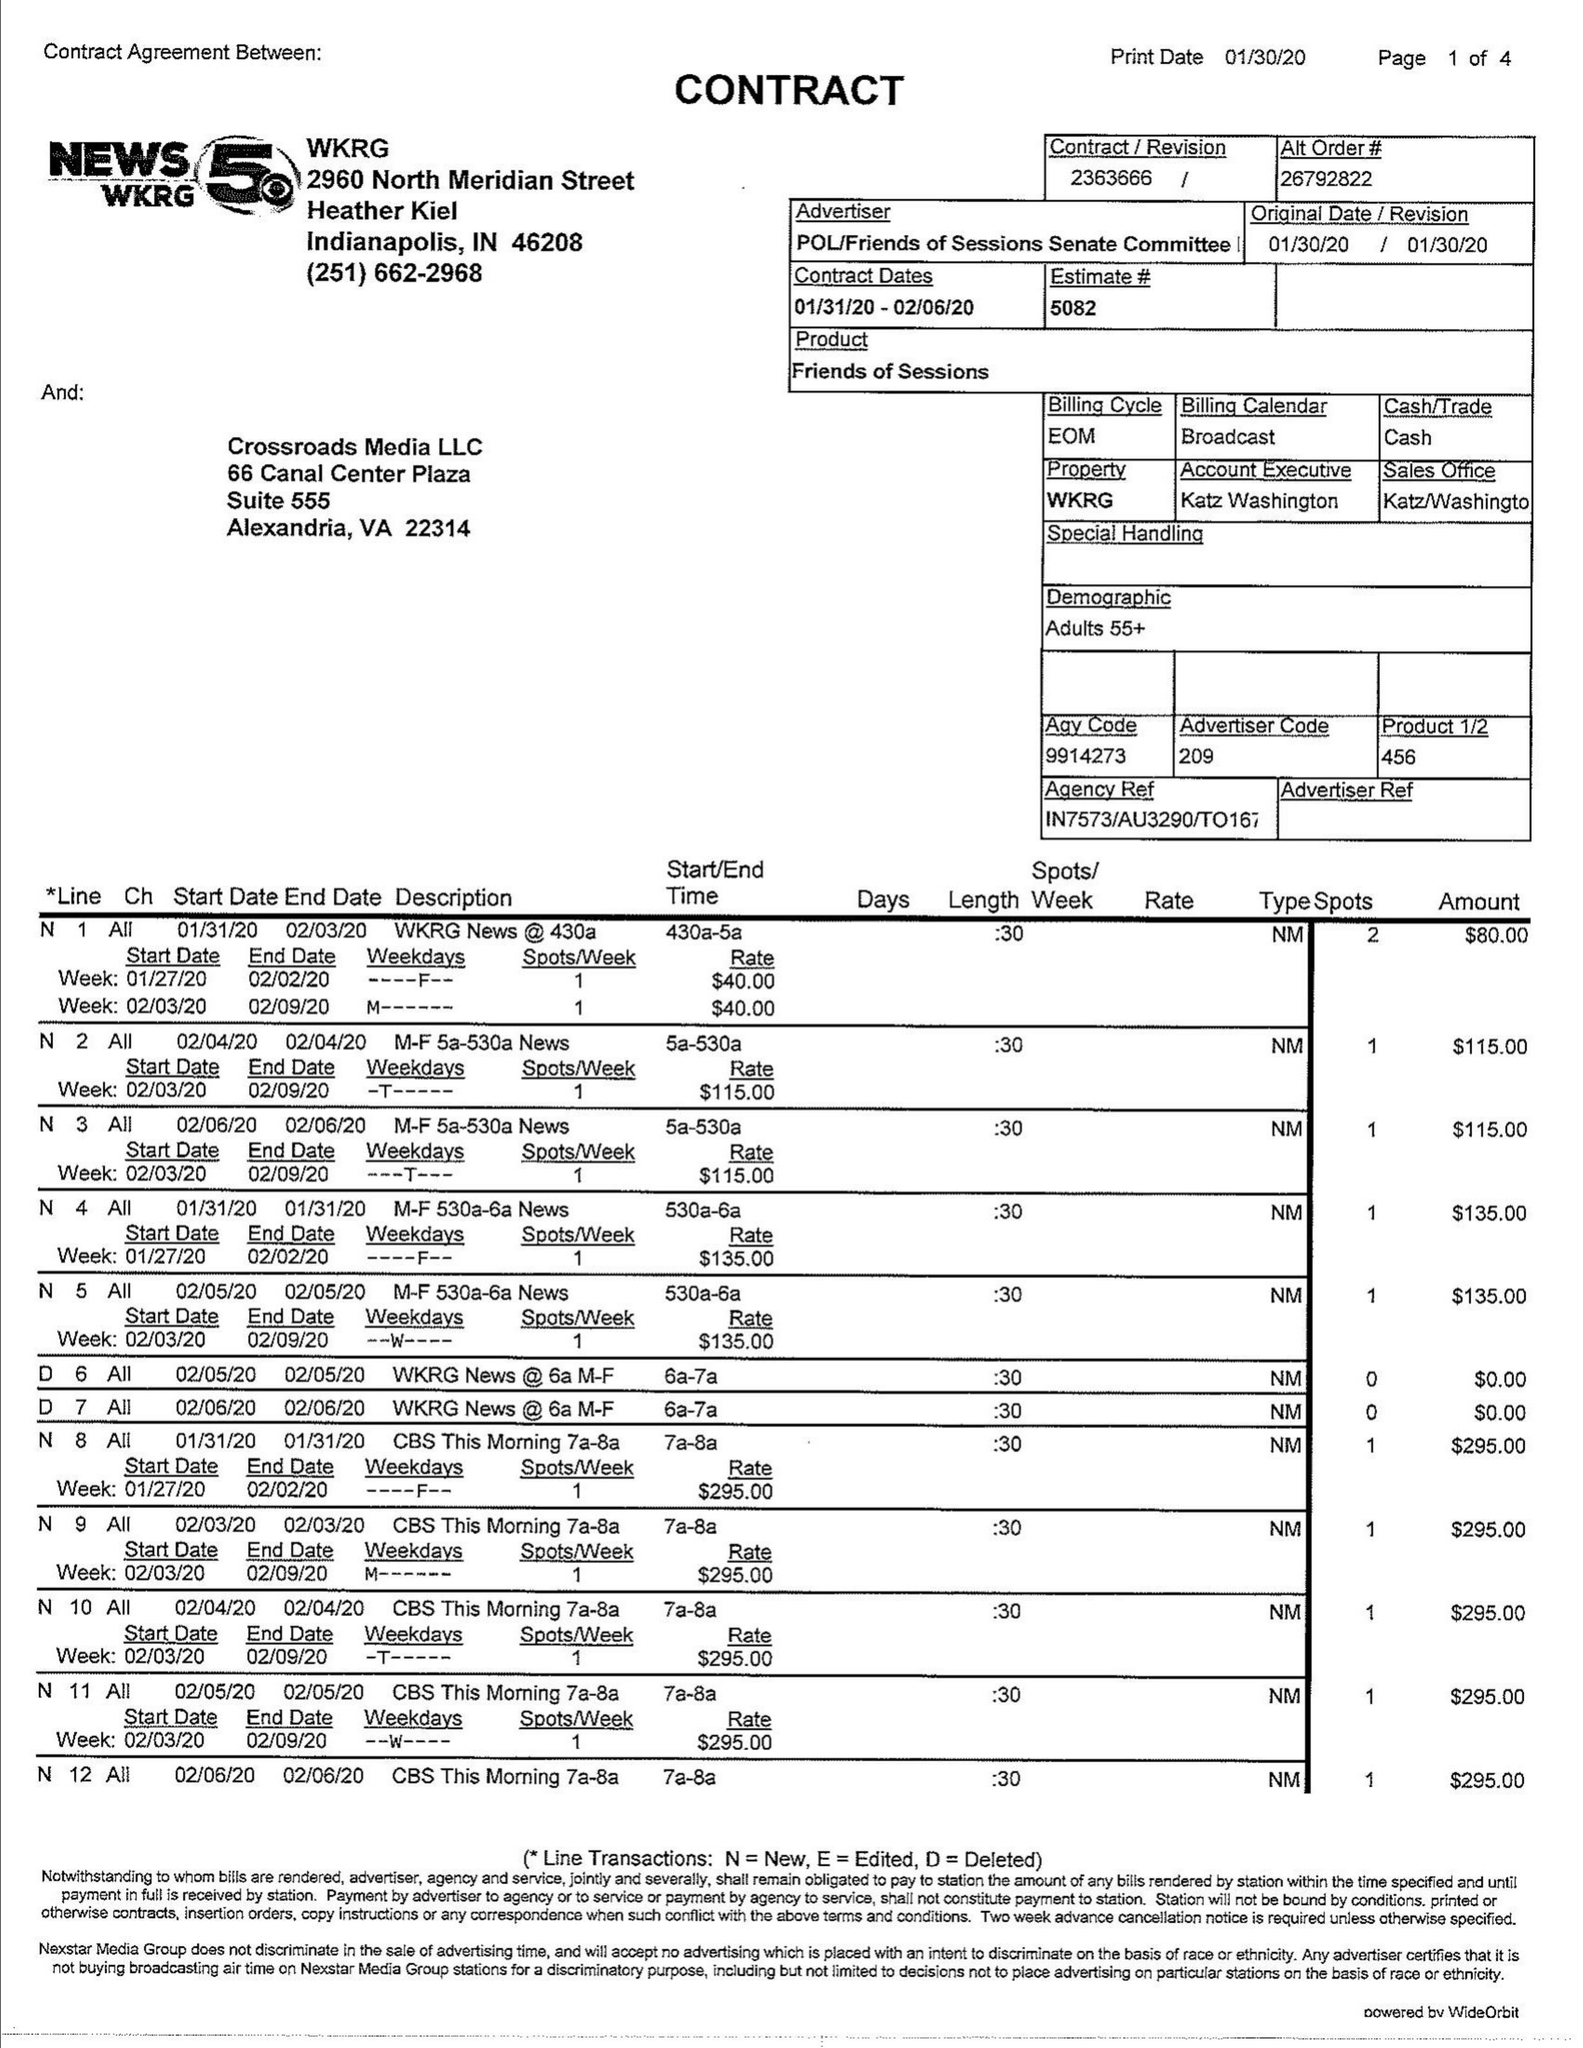What is the value for the flight_to?
Answer the question using a single word or phrase. 02/06/20 